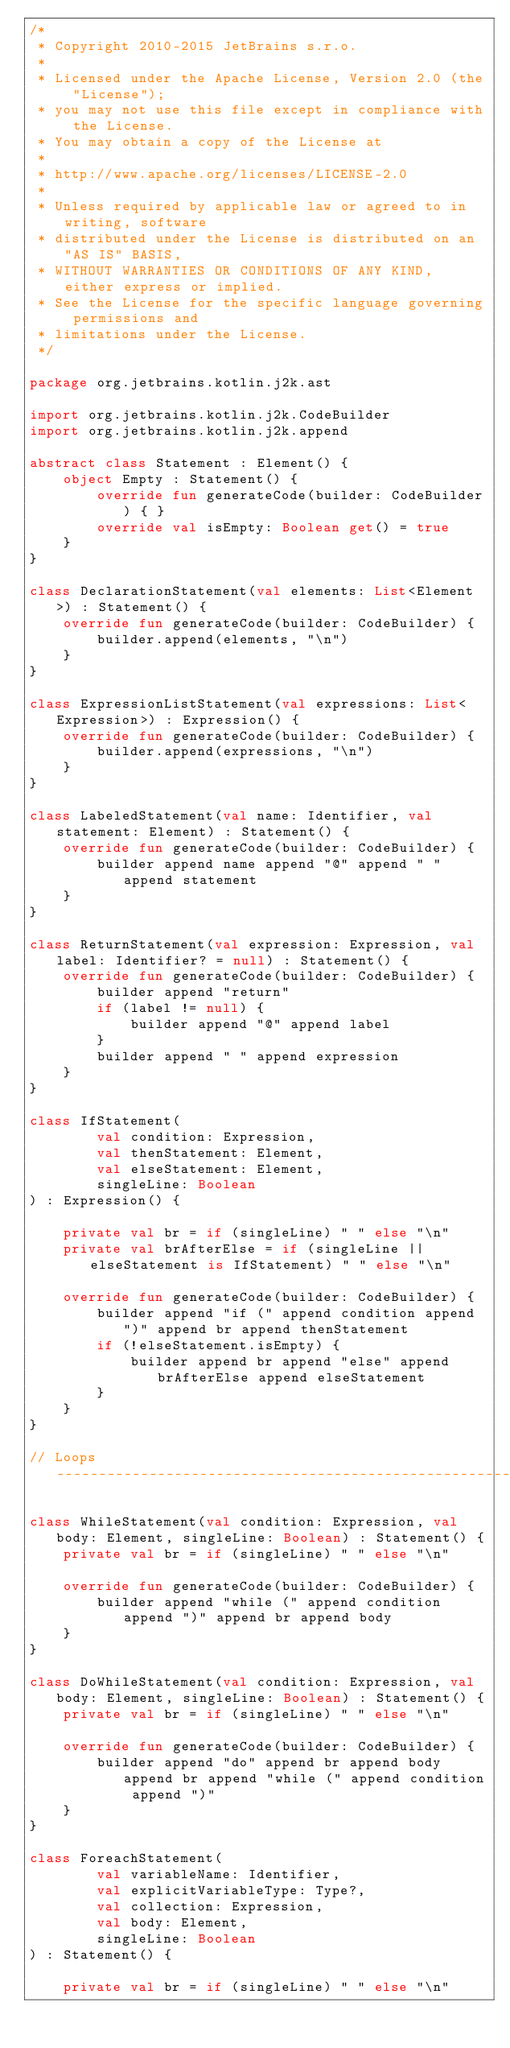Convert code to text. <code><loc_0><loc_0><loc_500><loc_500><_Kotlin_>/*
 * Copyright 2010-2015 JetBrains s.r.o.
 *
 * Licensed under the Apache License, Version 2.0 (the "License");
 * you may not use this file except in compliance with the License.
 * You may obtain a copy of the License at
 *
 * http://www.apache.org/licenses/LICENSE-2.0
 *
 * Unless required by applicable law or agreed to in writing, software
 * distributed under the License is distributed on an "AS IS" BASIS,
 * WITHOUT WARRANTIES OR CONDITIONS OF ANY KIND, either express or implied.
 * See the License for the specific language governing permissions and
 * limitations under the License.
 */

package org.jetbrains.kotlin.j2k.ast

import org.jetbrains.kotlin.j2k.CodeBuilder
import org.jetbrains.kotlin.j2k.append

abstract class Statement : Element() {
    object Empty : Statement() {
        override fun generateCode(builder: CodeBuilder) { }
        override val isEmpty: Boolean get() = true
    }
}

class DeclarationStatement(val elements: List<Element>) : Statement() {
    override fun generateCode(builder: CodeBuilder) {
        builder.append(elements, "\n")
    }
}

class ExpressionListStatement(val expressions: List<Expression>) : Expression() {
    override fun generateCode(builder: CodeBuilder) {
        builder.append(expressions, "\n")
    }
}

class LabeledStatement(val name: Identifier, val statement: Element) : Statement() {
    override fun generateCode(builder: CodeBuilder) {
        builder append name append "@" append " " append statement
    }
}

class ReturnStatement(val expression: Expression, val label: Identifier? = null) : Statement() {
    override fun generateCode(builder: CodeBuilder) {
        builder append "return"
        if (label != null) {
            builder append "@" append label
        }
        builder append " " append expression
    }
}

class IfStatement(
        val condition: Expression,
        val thenStatement: Element,
        val elseStatement: Element,
        singleLine: Boolean
) : Expression() {

    private val br = if (singleLine) " " else "\n"
    private val brAfterElse = if (singleLine || elseStatement is IfStatement) " " else "\n"

    override fun generateCode(builder: CodeBuilder) {
        builder append "if (" append condition append ")" append br append thenStatement
        if (!elseStatement.isEmpty) {
            builder append br append "else" append brAfterElse append elseStatement
        }
    }
}

// Loops --------------------------------------------------------------------------------------------------

class WhileStatement(val condition: Expression, val body: Element, singleLine: Boolean) : Statement() {
    private val br = if (singleLine) " " else "\n"

    override fun generateCode(builder: CodeBuilder) {
        builder append "while (" append condition append ")" append br append body
    }
}

class DoWhileStatement(val condition: Expression, val body: Element, singleLine: Boolean) : Statement() {
    private val br = if (singleLine) " " else "\n"

    override fun generateCode(builder: CodeBuilder) {
        builder append "do" append br append body append br append "while (" append condition append ")"
    }
}

class ForeachStatement(
        val variableName: Identifier,
        val explicitVariableType: Type?,
        val collection: Expression,
        val body: Element,
        singleLine: Boolean
) : Statement() {

    private val br = if (singleLine) " " else "\n"
</code> 